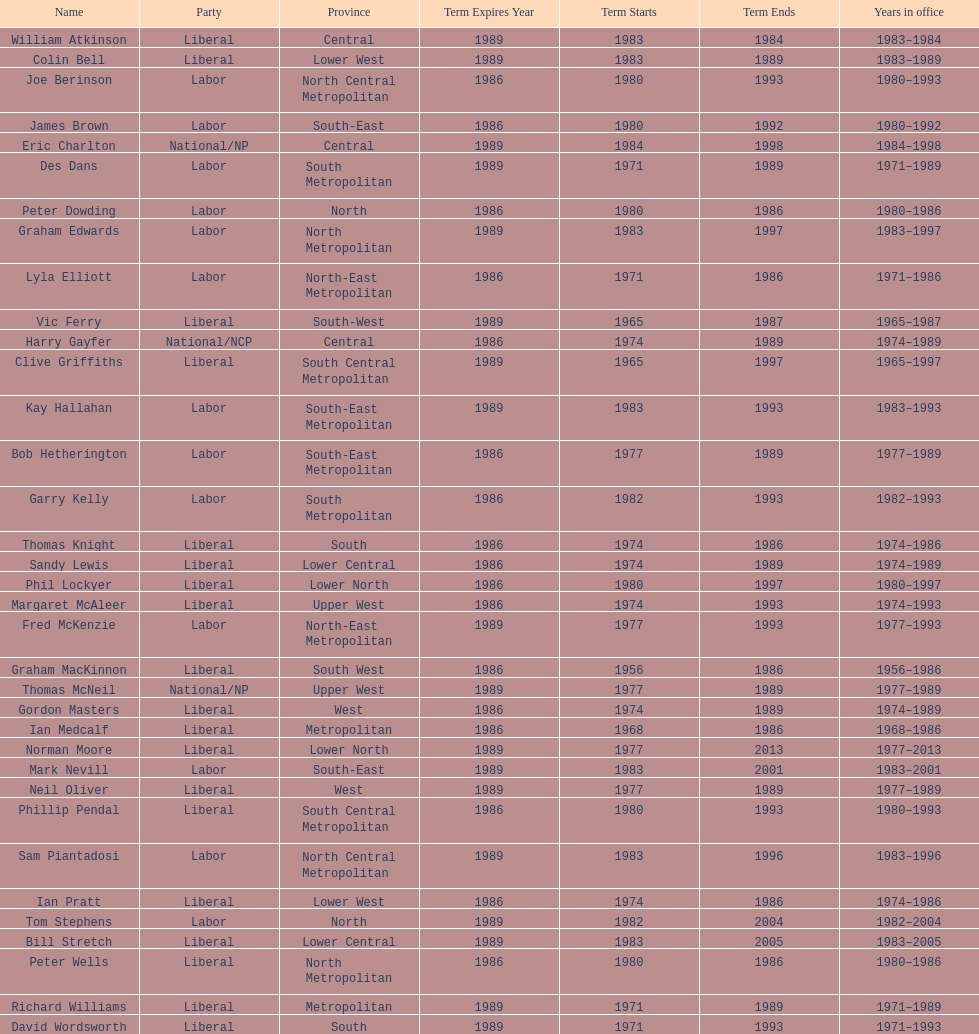What was phil lockyer's party? Liberal. Parse the table in full. {'header': ['Name', 'Party', 'Province', 'Term Expires Year', 'Term Starts', 'Term Ends', 'Years in office'], 'rows': [['William Atkinson', 'Liberal', 'Central', '1989', '1983', '1984', '1983–1984'], ['Colin Bell', 'Liberal', 'Lower West', '1989', '1983', '1989', '1983–1989'], ['Joe Berinson', 'Labor', 'North Central Metropolitan', '1986', '1980', '1993', '1980–1993'], ['James Brown', 'Labor', 'South-East', '1986', '1980', '1992', '1980–1992'], ['Eric Charlton', 'National/NP', 'Central', '1989', '1984', '1998', '1984–1998'], ['Des Dans', 'Labor', 'South Metropolitan', '1989', '1971', '1989', '1971–1989'], ['Peter Dowding', 'Labor', 'North', '1986', '1980', '1986', '1980–1986'], ['Graham Edwards', 'Labor', 'North Metropolitan', '1989', '1983', '1997', '1983–1997'], ['Lyla Elliott', 'Labor', 'North-East Metropolitan', '1986', '1971', '1986', '1971–1986'], ['Vic Ferry', 'Liberal', 'South-West', '1989', '1965', '1987', '1965–1987'], ['Harry Gayfer', 'National/NCP', 'Central', '1986', '1974', '1989', '1974–1989'], ['Clive Griffiths', 'Liberal', 'South Central Metropolitan', '1989', '1965', '1997', '1965–1997'], ['Kay Hallahan', 'Labor', 'South-East Metropolitan', '1989', '1983', '1993', '1983–1993'], ['Bob Hetherington', 'Labor', 'South-East Metropolitan', '1986', '1977', '1989', '1977–1989'], ['Garry Kelly', 'Labor', 'South Metropolitan', '1986', '1982', '1993', '1982–1993'], ['Thomas Knight', 'Liberal', 'South', '1986', '1974', '1986', '1974–1986'], ['Sandy Lewis', 'Liberal', 'Lower Central', '1986', '1974', '1989', '1974–1989'], ['Phil Lockyer', 'Liberal', 'Lower North', '1986', '1980', '1997', '1980–1997'], ['Margaret McAleer', 'Liberal', 'Upper West', '1986', '1974', '1993', '1974–1993'], ['Fred McKenzie', 'Labor', 'North-East Metropolitan', '1989', '1977', '1993', '1977–1993'], ['Graham MacKinnon', 'Liberal', 'South West', '1986', '1956', '1986', '1956–1986'], ['Thomas McNeil', 'National/NP', 'Upper West', '1989', '1977', '1989', '1977–1989'], ['Gordon Masters', 'Liberal', 'West', '1986', '1974', '1989', '1974–1989'], ['Ian Medcalf', 'Liberal', 'Metropolitan', '1986', '1968', '1986', '1968–1986'], ['Norman Moore', 'Liberal', 'Lower North', '1989', '1977', '2013', '1977–2013'], ['Mark Nevill', 'Labor', 'South-East', '1989', '1983', '2001', '1983–2001'], ['Neil Oliver', 'Liberal', 'West', '1989', '1977', '1989', '1977–1989'], ['Phillip Pendal', 'Liberal', 'South Central Metropolitan', '1986', '1980', '1993', '1980–1993'], ['Sam Piantadosi', 'Labor', 'North Central Metropolitan', '1989', '1983', '1996', '1983–1996'], ['Ian Pratt', 'Liberal', 'Lower West', '1986', '1974', '1986', '1974–1986'], ['Tom Stephens', 'Labor', 'North', '1989', '1982', '2004', '1982–2004'], ['Bill Stretch', 'Liberal', 'Lower Central', '1989', '1983', '2005', '1983–2005'], ['Peter Wells', 'Liberal', 'North Metropolitan', '1986', '1980', '1986', '1980–1986'], ['Richard Williams', 'Liberal', 'Metropolitan', '1989', '1971', '1989', '1971–1989'], ['David Wordsworth', 'Liberal', 'South', '1989', '1971', '1993', '1971–1993']]} 